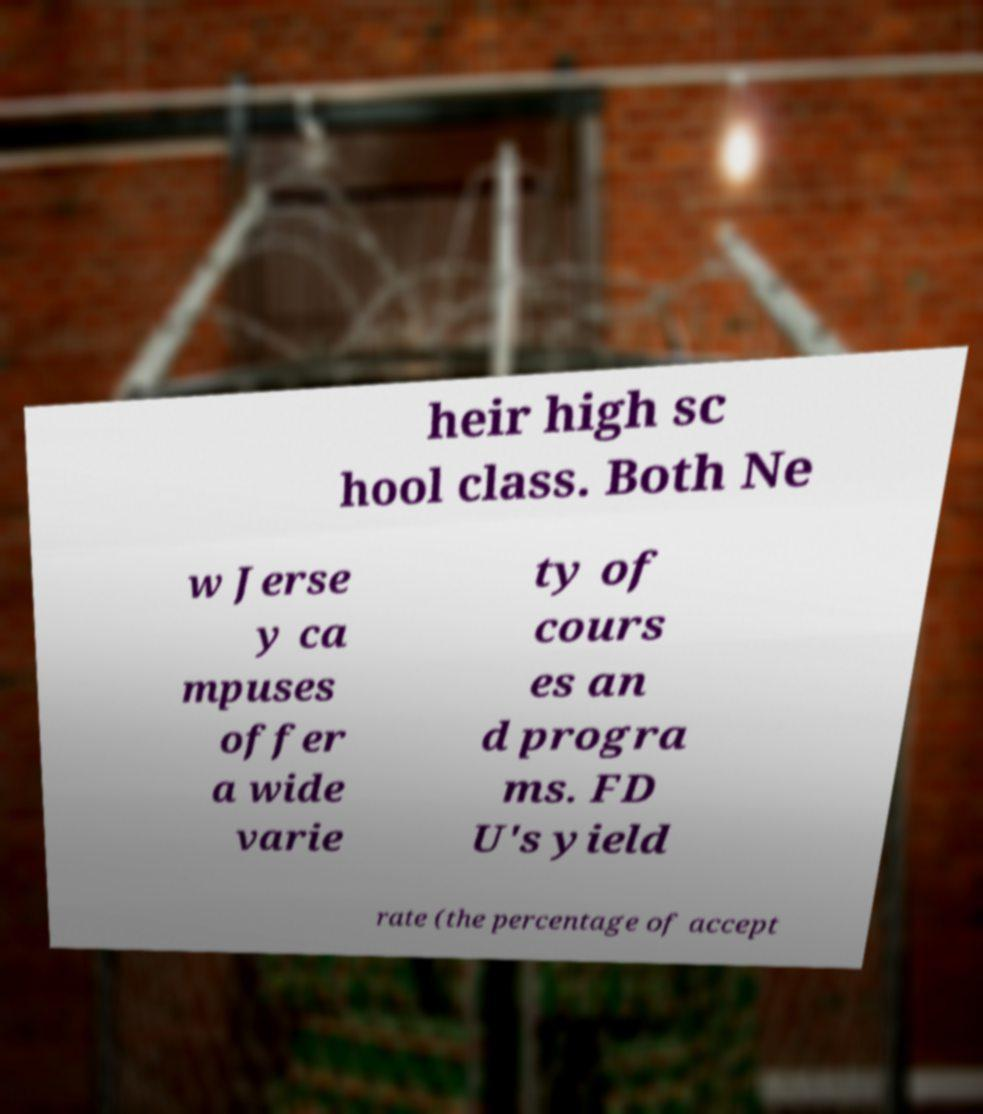Can you accurately transcribe the text from the provided image for me? heir high sc hool class. Both Ne w Jerse y ca mpuses offer a wide varie ty of cours es an d progra ms. FD U's yield rate (the percentage of accept 